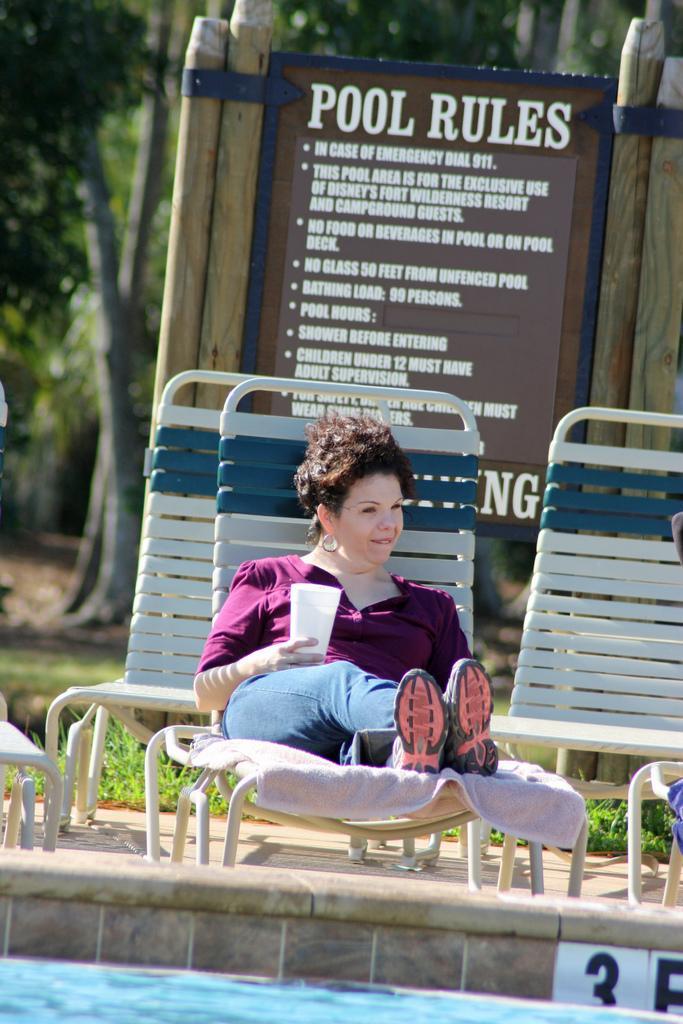Could you give a brief overview of what you see in this image? In this image there is water, a person holding a glass and laying on the swimming pool bench , and at the background there are swimming pool benches, board to the wooden poles, grass, plants, trees. 